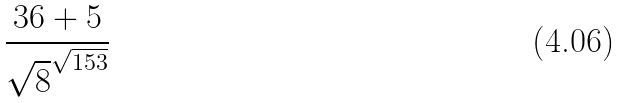<formula> <loc_0><loc_0><loc_500><loc_500>\frac { 3 6 + 5 } { \sqrt { 8 } ^ { \sqrt { 1 5 3 } } }</formula> 